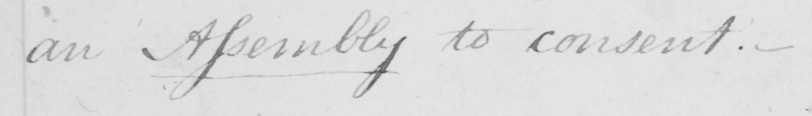Can you tell me what this handwritten text says? an Assembly to consent .  _ 